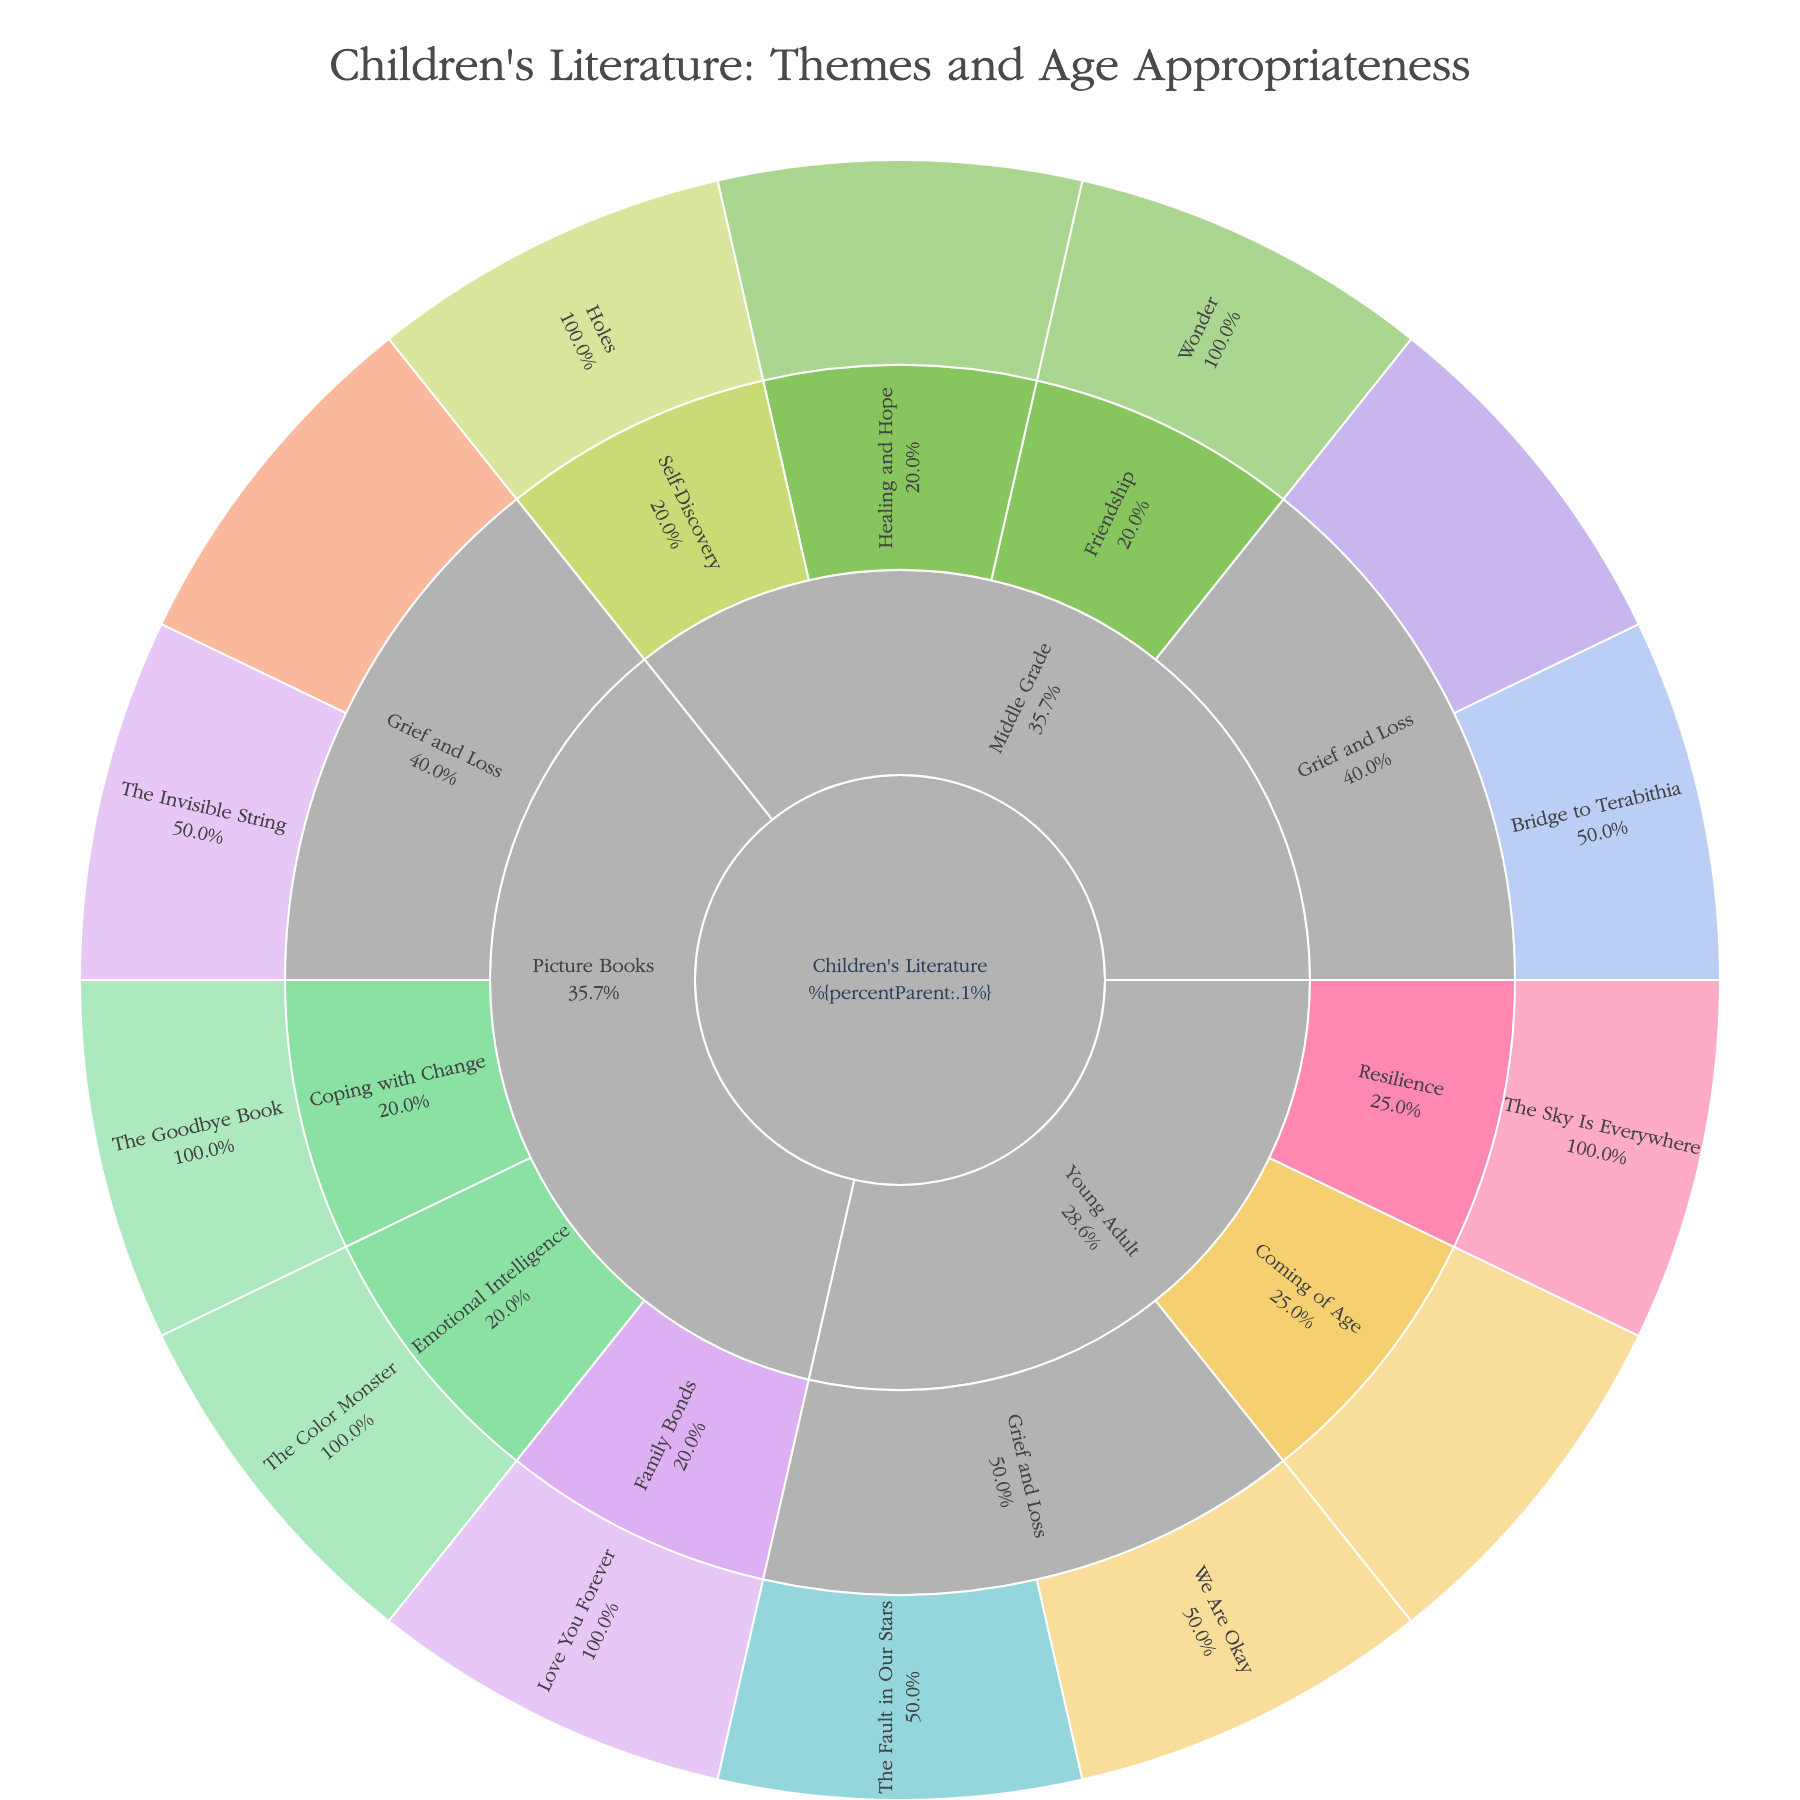How many Picture Books in the plot address the theme of Grief and Loss? First, locate the "Picture Books" category in the sunburst plot, then identify and count the subcategories under "Grief and Loss". The book titles under this theme are "The Invisible String" and "The Heart and the Bottle". So, the count is 2.
Answer: 2 Which age group primarily targets middle-grade books addressing Grief and Loss? Identify the "Middle Grade" category, then the "Grief and Loss" subcategory. The specified age groups for books in this theme are 9-12 and 10-13.
Answer: 9-13 What is the most common theme in Young Adult literature based on the plot? Locate the "Young Adult" category, then observe the size proportions of each subcategory. "Grief and Loss" is the predominant theme, containing the most book titles within this age group.
Answer: Grief and Loss Are there more books in the Picture Books or Middle Grade category that address Grief and Loss? Identify and compare the count of books under the "Grief and Loss" theme within both "Picture Books" and "Middle Grade" categories. Picture Books have 2, and Middle Grade has 2.
Answer: Equal Which theme in Picture Books targets the youngest age group? Look within the "Picture Books" category, then find the subcategory with the youngest age group. The book "The Goodbye Book" under "Coping with Change" targets ages 3-7, which is the youngest group listed.
Answer: Coping with Change How does the number of books addressing Grief and Loss in Young Adult compare to Middle Grade? Count the number of books under "Grief and Loss" for Young Adult and Middle Grade. The counts are 2 for Middle Grade and 2 for Young Adult.
Answer: Equal Are any books in the plot suitable for children under four years old? Scan the age groups for all categories and see if any mention "under 4". The youngest mentioned is 3 years old.
Answer: No What age group does "The Science of Breakable Things" target, and what theme does it address? Locate "Middle Grade" category, find "The Science of Breakable Things" under the "Healing and Hope" theme. It targets ages 8-12.
Answer: 8-12, Healing and Hope What is the range of age groups targeted in the Picture Books category? Inspect all age groups specified within the "Picture Books" category. They range from 3 to 9 years old.
Answer: 3-9 years Is there a greater variety of themes in Picture Books or Middle Grade books? Compare the distinct themes listed under "Picture Books" (Grief and Loss, Coping with Change, Emotional Intelligence, Family Bonds) and "Middle Grade" (Grief and Loss, Healing and Hope, Friendship, Self-Discovery). Both categories have four distinct themes.
Answer: Equal 